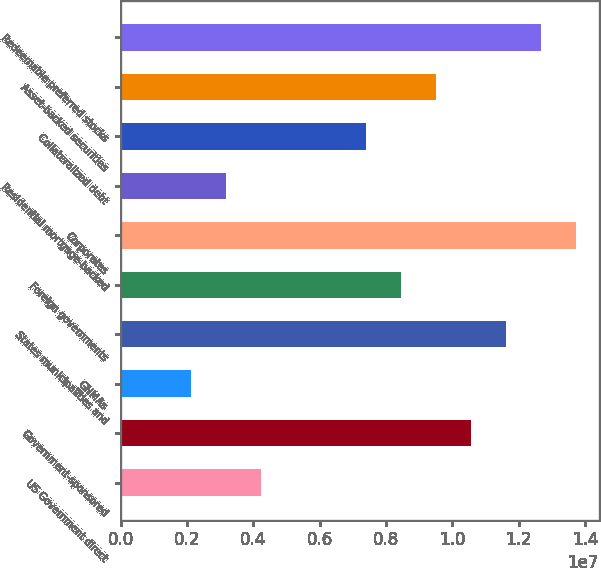<chart> <loc_0><loc_0><loc_500><loc_500><bar_chart><fcel>US Government direct<fcel>Government-sponsored<fcel>GNMAs<fcel>States municipalities and<fcel>Foreign governments<fcel>Corporates<fcel>Residential mortgage-backed<fcel>Collateralized debt<fcel>Asset-backed securities<fcel>Redeemable preferred stocks<nl><fcel>4.22414e+06<fcel>1.05602e+07<fcel>2.11212e+06<fcel>1.16162e+07<fcel>8.44817e+06<fcel>1.37282e+07<fcel>3.16813e+06<fcel>7.39216e+06<fcel>9.50418e+06<fcel>1.26722e+07<nl></chart> 